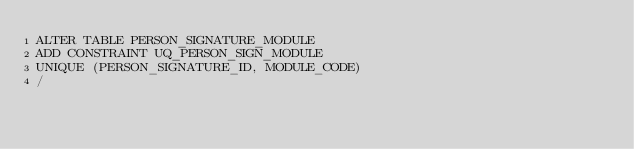<code> <loc_0><loc_0><loc_500><loc_500><_SQL_>ALTER TABLE PERSON_SIGNATURE_MODULE 
ADD CONSTRAINT UQ_PERSON_SIGN_MODULE 
UNIQUE (PERSON_SIGNATURE_ID, MODULE_CODE) 
/

</code> 